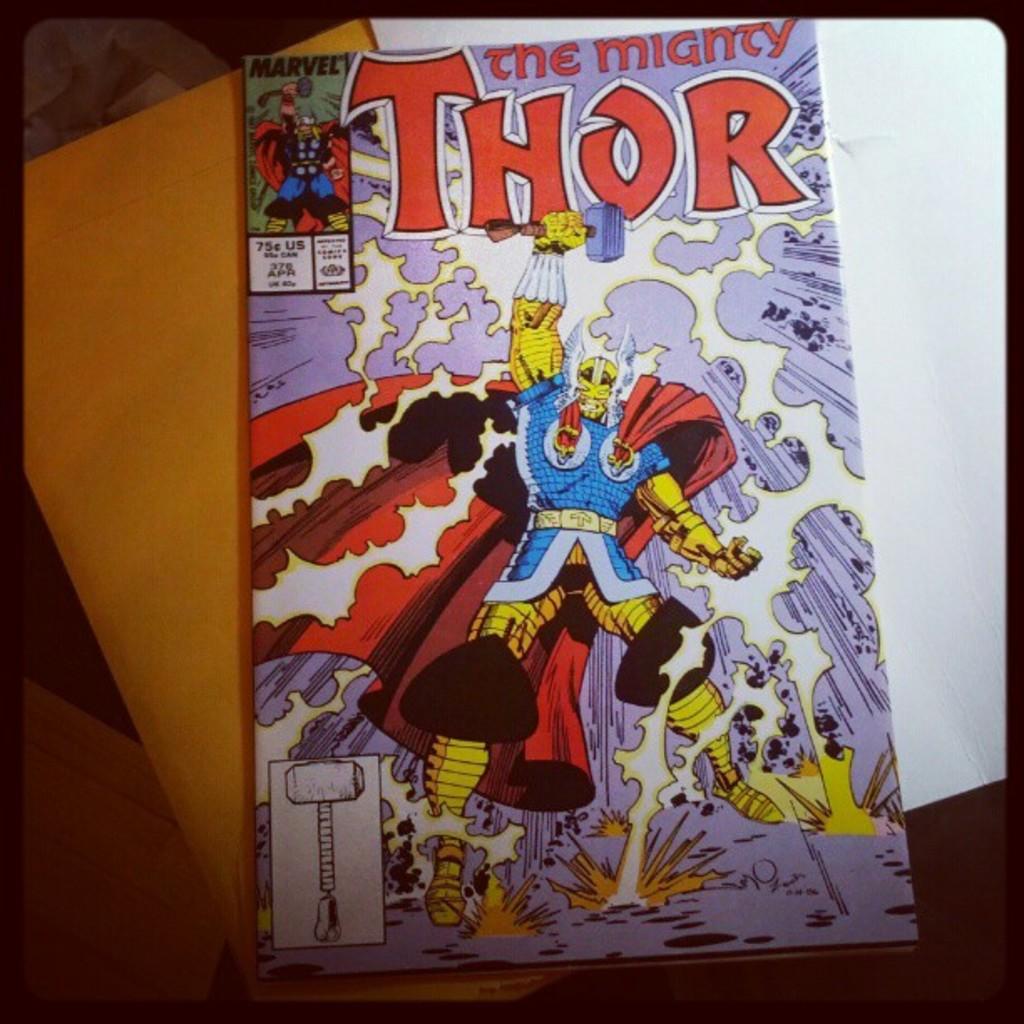How much does this comic cost?
Provide a short and direct response. 75 cents. 